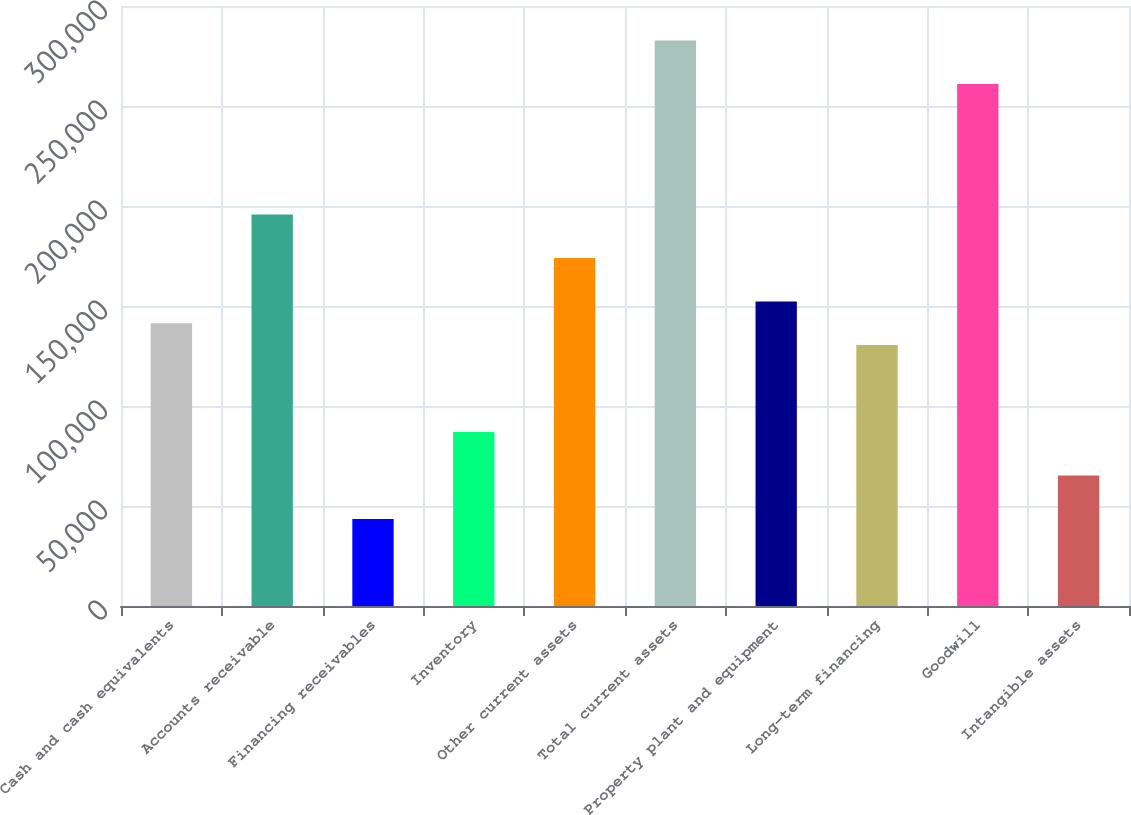Convert chart. <chart><loc_0><loc_0><loc_500><loc_500><bar_chart><fcel>Cash and cash equivalents<fcel>Accounts receivable<fcel>Financing receivables<fcel>Inventory<fcel>Other current assets<fcel>Total current assets<fcel>Property plant and equipment<fcel>Long-term financing<fcel>Goodwill<fcel>Intangible assets<nl><fcel>141392<fcel>195766<fcel>43519.2<fcel>87018.4<fcel>174017<fcel>282765<fcel>152267<fcel>130518<fcel>261015<fcel>65268.8<nl></chart> 